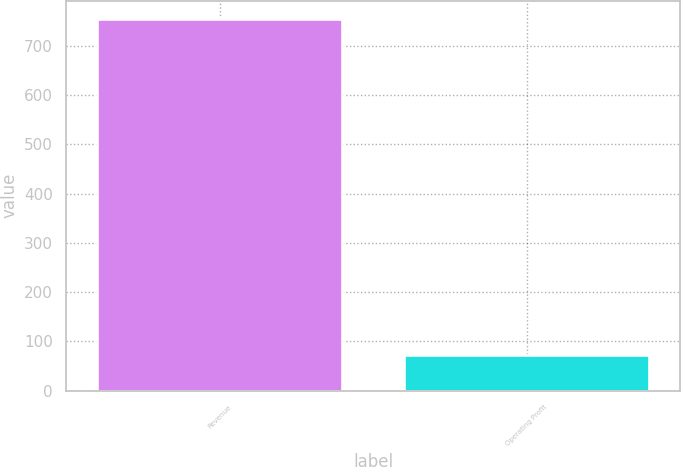Convert chart. <chart><loc_0><loc_0><loc_500><loc_500><bar_chart><fcel>Revenue<fcel>Operating Profit<nl><fcel>753.4<fcel>71.6<nl></chart> 